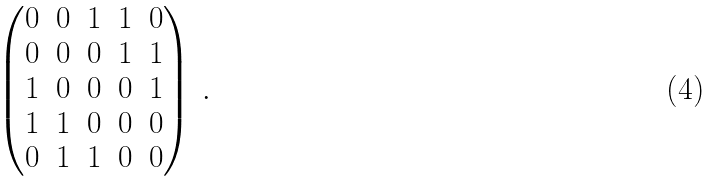<formula> <loc_0><loc_0><loc_500><loc_500>\begin{pmatrix} 0 & 0 & 1 & 1 & 0 \\ 0 & 0 & 0 & 1 & 1 \\ 1 & 0 & 0 & 0 & 1 \\ 1 & 1 & 0 & 0 & 0 \\ 0 & 1 & 1 & 0 & 0 \end{pmatrix} \, .</formula> 